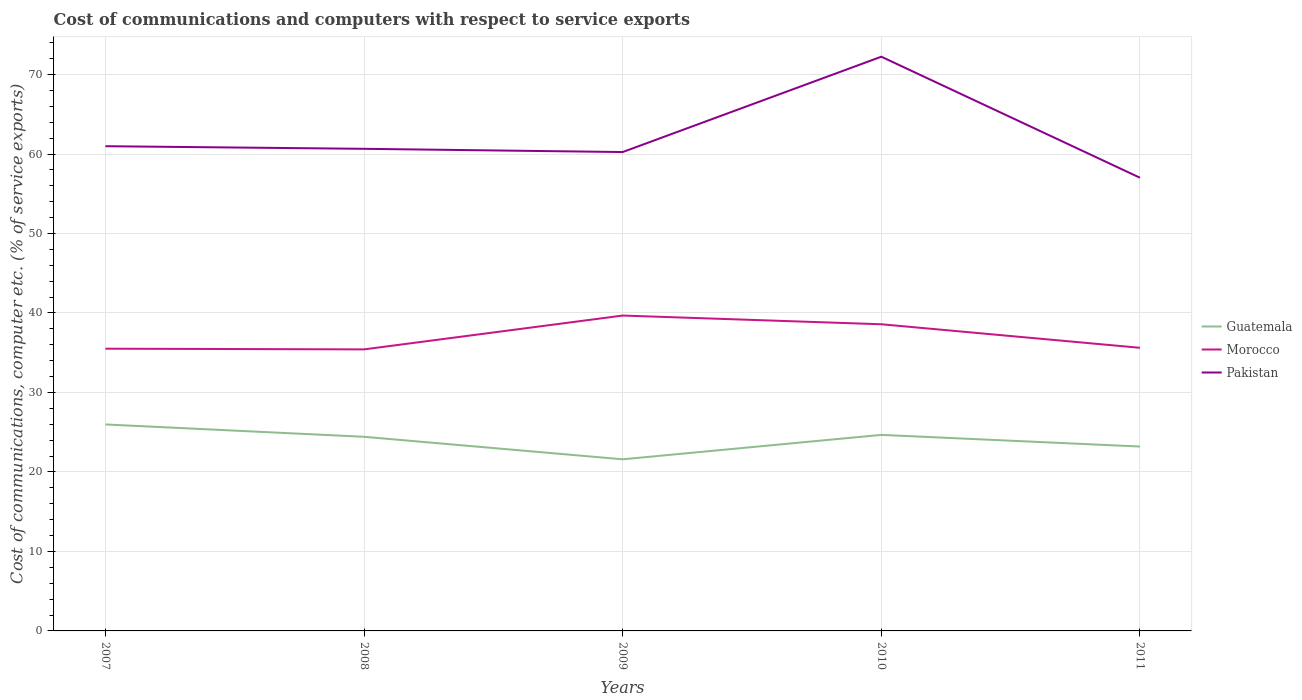Does the line corresponding to Pakistan intersect with the line corresponding to Guatemala?
Ensure brevity in your answer.  No. Is the number of lines equal to the number of legend labels?
Give a very brief answer. Yes. Across all years, what is the maximum cost of communications and computers in Morocco?
Provide a short and direct response. 35.42. What is the total cost of communications and computers in Morocco in the graph?
Ensure brevity in your answer.  -3.16. What is the difference between the highest and the second highest cost of communications and computers in Morocco?
Your answer should be very brief. 4.26. What is the difference between the highest and the lowest cost of communications and computers in Morocco?
Provide a short and direct response. 2. What is the difference between two consecutive major ticks on the Y-axis?
Make the answer very short. 10. Does the graph contain grids?
Your response must be concise. Yes. How many legend labels are there?
Make the answer very short. 3. How are the legend labels stacked?
Your answer should be compact. Vertical. What is the title of the graph?
Keep it short and to the point. Cost of communications and computers with respect to service exports. Does "Georgia" appear as one of the legend labels in the graph?
Offer a very short reply. No. What is the label or title of the X-axis?
Your answer should be very brief. Years. What is the label or title of the Y-axis?
Offer a very short reply. Cost of communications, computer etc. (% of service exports). What is the Cost of communications, computer etc. (% of service exports) of Guatemala in 2007?
Provide a short and direct response. 25.98. What is the Cost of communications, computer etc. (% of service exports) of Morocco in 2007?
Offer a very short reply. 35.51. What is the Cost of communications, computer etc. (% of service exports) in Pakistan in 2007?
Provide a succinct answer. 60.98. What is the Cost of communications, computer etc. (% of service exports) in Guatemala in 2008?
Offer a very short reply. 24.42. What is the Cost of communications, computer etc. (% of service exports) of Morocco in 2008?
Offer a very short reply. 35.42. What is the Cost of communications, computer etc. (% of service exports) of Pakistan in 2008?
Ensure brevity in your answer.  60.65. What is the Cost of communications, computer etc. (% of service exports) in Guatemala in 2009?
Ensure brevity in your answer.  21.59. What is the Cost of communications, computer etc. (% of service exports) in Morocco in 2009?
Make the answer very short. 39.68. What is the Cost of communications, computer etc. (% of service exports) of Pakistan in 2009?
Provide a short and direct response. 60.25. What is the Cost of communications, computer etc. (% of service exports) of Guatemala in 2010?
Keep it short and to the point. 24.66. What is the Cost of communications, computer etc. (% of service exports) of Morocco in 2010?
Offer a very short reply. 38.58. What is the Cost of communications, computer etc. (% of service exports) of Pakistan in 2010?
Give a very brief answer. 72.24. What is the Cost of communications, computer etc. (% of service exports) in Guatemala in 2011?
Provide a short and direct response. 23.2. What is the Cost of communications, computer etc. (% of service exports) of Morocco in 2011?
Offer a very short reply. 35.62. What is the Cost of communications, computer etc. (% of service exports) in Pakistan in 2011?
Your answer should be compact. 57.02. Across all years, what is the maximum Cost of communications, computer etc. (% of service exports) in Guatemala?
Your answer should be very brief. 25.98. Across all years, what is the maximum Cost of communications, computer etc. (% of service exports) in Morocco?
Keep it short and to the point. 39.68. Across all years, what is the maximum Cost of communications, computer etc. (% of service exports) of Pakistan?
Provide a succinct answer. 72.24. Across all years, what is the minimum Cost of communications, computer etc. (% of service exports) in Guatemala?
Offer a terse response. 21.59. Across all years, what is the minimum Cost of communications, computer etc. (% of service exports) of Morocco?
Your answer should be compact. 35.42. Across all years, what is the minimum Cost of communications, computer etc. (% of service exports) of Pakistan?
Provide a succinct answer. 57.02. What is the total Cost of communications, computer etc. (% of service exports) in Guatemala in the graph?
Ensure brevity in your answer.  119.85. What is the total Cost of communications, computer etc. (% of service exports) in Morocco in the graph?
Your answer should be very brief. 184.81. What is the total Cost of communications, computer etc. (% of service exports) in Pakistan in the graph?
Make the answer very short. 311.15. What is the difference between the Cost of communications, computer etc. (% of service exports) of Guatemala in 2007 and that in 2008?
Ensure brevity in your answer.  1.55. What is the difference between the Cost of communications, computer etc. (% of service exports) in Morocco in 2007 and that in 2008?
Make the answer very short. 0.09. What is the difference between the Cost of communications, computer etc. (% of service exports) in Pakistan in 2007 and that in 2008?
Your response must be concise. 0.33. What is the difference between the Cost of communications, computer etc. (% of service exports) of Guatemala in 2007 and that in 2009?
Make the answer very short. 4.38. What is the difference between the Cost of communications, computer etc. (% of service exports) in Morocco in 2007 and that in 2009?
Make the answer very short. -4.17. What is the difference between the Cost of communications, computer etc. (% of service exports) of Pakistan in 2007 and that in 2009?
Offer a terse response. 0.74. What is the difference between the Cost of communications, computer etc. (% of service exports) in Guatemala in 2007 and that in 2010?
Keep it short and to the point. 1.31. What is the difference between the Cost of communications, computer etc. (% of service exports) of Morocco in 2007 and that in 2010?
Your response must be concise. -3.07. What is the difference between the Cost of communications, computer etc. (% of service exports) of Pakistan in 2007 and that in 2010?
Offer a terse response. -11.26. What is the difference between the Cost of communications, computer etc. (% of service exports) of Guatemala in 2007 and that in 2011?
Ensure brevity in your answer.  2.78. What is the difference between the Cost of communications, computer etc. (% of service exports) of Morocco in 2007 and that in 2011?
Ensure brevity in your answer.  -0.11. What is the difference between the Cost of communications, computer etc. (% of service exports) in Pakistan in 2007 and that in 2011?
Provide a short and direct response. 3.96. What is the difference between the Cost of communications, computer etc. (% of service exports) in Guatemala in 2008 and that in 2009?
Your response must be concise. 2.83. What is the difference between the Cost of communications, computer etc. (% of service exports) in Morocco in 2008 and that in 2009?
Your answer should be very brief. -4.26. What is the difference between the Cost of communications, computer etc. (% of service exports) in Pakistan in 2008 and that in 2009?
Offer a very short reply. 0.41. What is the difference between the Cost of communications, computer etc. (% of service exports) in Guatemala in 2008 and that in 2010?
Offer a very short reply. -0.24. What is the difference between the Cost of communications, computer etc. (% of service exports) of Morocco in 2008 and that in 2010?
Ensure brevity in your answer.  -3.16. What is the difference between the Cost of communications, computer etc. (% of service exports) of Pakistan in 2008 and that in 2010?
Ensure brevity in your answer.  -11.59. What is the difference between the Cost of communications, computer etc. (% of service exports) of Guatemala in 2008 and that in 2011?
Your answer should be compact. 1.22. What is the difference between the Cost of communications, computer etc. (% of service exports) in Morocco in 2008 and that in 2011?
Your answer should be very brief. -0.2. What is the difference between the Cost of communications, computer etc. (% of service exports) of Pakistan in 2008 and that in 2011?
Make the answer very short. 3.64. What is the difference between the Cost of communications, computer etc. (% of service exports) in Guatemala in 2009 and that in 2010?
Keep it short and to the point. -3.07. What is the difference between the Cost of communications, computer etc. (% of service exports) in Morocco in 2009 and that in 2010?
Provide a succinct answer. 1.1. What is the difference between the Cost of communications, computer etc. (% of service exports) of Pakistan in 2009 and that in 2010?
Provide a succinct answer. -12. What is the difference between the Cost of communications, computer etc. (% of service exports) in Guatemala in 2009 and that in 2011?
Your response must be concise. -1.61. What is the difference between the Cost of communications, computer etc. (% of service exports) in Morocco in 2009 and that in 2011?
Make the answer very short. 4.06. What is the difference between the Cost of communications, computer etc. (% of service exports) of Pakistan in 2009 and that in 2011?
Your answer should be very brief. 3.23. What is the difference between the Cost of communications, computer etc. (% of service exports) of Guatemala in 2010 and that in 2011?
Your answer should be very brief. 1.47. What is the difference between the Cost of communications, computer etc. (% of service exports) in Morocco in 2010 and that in 2011?
Ensure brevity in your answer.  2.96. What is the difference between the Cost of communications, computer etc. (% of service exports) of Pakistan in 2010 and that in 2011?
Provide a succinct answer. 15.22. What is the difference between the Cost of communications, computer etc. (% of service exports) in Guatemala in 2007 and the Cost of communications, computer etc. (% of service exports) in Morocco in 2008?
Provide a succinct answer. -9.44. What is the difference between the Cost of communications, computer etc. (% of service exports) of Guatemala in 2007 and the Cost of communications, computer etc. (% of service exports) of Pakistan in 2008?
Offer a very short reply. -34.68. What is the difference between the Cost of communications, computer etc. (% of service exports) of Morocco in 2007 and the Cost of communications, computer etc. (% of service exports) of Pakistan in 2008?
Offer a terse response. -25.15. What is the difference between the Cost of communications, computer etc. (% of service exports) in Guatemala in 2007 and the Cost of communications, computer etc. (% of service exports) in Morocco in 2009?
Provide a succinct answer. -13.7. What is the difference between the Cost of communications, computer etc. (% of service exports) in Guatemala in 2007 and the Cost of communications, computer etc. (% of service exports) in Pakistan in 2009?
Provide a succinct answer. -34.27. What is the difference between the Cost of communications, computer etc. (% of service exports) of Morocco in 2007 and the Cost of communications, computer etc. (% of service exports) of Pakistan in 2009?
Your answer should be compact. -24.74. What is the difference between the Cost of communications, computer etc. (% of service exports) in Guatemala in 2007 and the Cost of communications, computer etc. (% of service exports) in Morocco in 2010?
Offer a very short reply. -12.61. What is the difference between the Cost of communications, computer etc. (% of service exports) of Guatemala in 2007 and the Cost of communications, computer etc. (% of service exports) of Pakistan in 2010?
Your response must be concise. -46.27. What is the difference between the Cost of communications, computer etc. (% of service exports) in Morocco in 2007 and the Cost of communications, computer etc. (% of service exports) in Pakistan in 2010?
Your answer should be very brief. -36.74. What is the difference between the Cost of communications, computer etc. (% of service exports) in Guatemala in 2007 and the Cost of communications, computer etc. (% of service exports) in Morocco in 2011?
Keep it short and to the point. -9.64. What is the difference between the Cost of communications, computer etc. (% of service exports) in Guatemala in 2007 and the Cost of communications, computer etc. (% of service exports) in Pakistan in 2011?
Provide a short and direct response. -31.04. What is the difference between the Cost of communications, computer etc. (% of service exports) in Morocco in 2007 and the Cost of communications, computer etc. (% of service exports) in Pakistan in 2011?
Provide a succinct answer. -21.51. What is the difference between the Cost of communications, computer etc. (% of service exports) of Guatemala in 2008 and the Cost of communications, computer etc. (% of service exports) of Morocco in 2009?
Offer a terse response. -15.25. What is the difference between the Cost of communications, computer etc. (% of service exports) in Guatemala in 2008 and the Cost of communications, computer etc. (% of service exports) in Pakistan in 2009?
Offer a very short reply. -35.82. What is the difference between the Cost of communications, computer etc. (% of service exports) in Morocco in 2008 and the Cost of communications, computer etc. (% of service exports) in Pakistan in 2009?
Provide a short and direct response. -24.83. What is the difference between the Cost of communications, computer etc. (% of service exports) of Guatemala in 2008 and the Cost of communications, computer etc. (% of service exports) of Morocco in 2010?
Offer a terse response. -14.16. What is the difference between the Cost of communications, computer etc. (% of service exports) of Guatemala in 2008 and the Cost of communications, computer etc. (% of service exports) of Pakistan in 2010?
Give a very brief answer. -47.82. What is the difference between the Cost of communications, computer etc. (% of service exports) of Morocco in 2008 and the Cost of communications, computer etc. (% of service exports) of Pakistan in 2010?
Make the answer very short. -36.82. What is the difference between the Cost of communications, computer etc. (% of service exports) of Guatemala in 2008 and the Cost of communications, computer etc. (% of service exports) of Morocco in 2011?
Offer a very short reply. -11.2. What is the difference between the Cost of communications, computer etc. (% of service exports) of Guatemala in 2008 and the Cost of communications, computer etc. (% of service exports) of Pakistan in 2011?
Ensure brevity in your answer.  -32.6. What is the difference between the Cost of communications, computer etc. (% of service exports) of Morocco in 2008 and the Cost of communications, computer etc. (% of service exports) of Pakistan in 2011?
Provide a short and direct response. -21.6. What is the difference between the Cost of communications, computer etc. (% of service exports) of Guatemala in 2009 and the Cost of communications, computer etc. (% of service exports) of Morocco in 2010?
Offer a very short reply. -16.99. What is the difference between the Cost of communications, computer etc. (% of service exports) of Guatemala in 2009 and the Cost of communications, computer etc. (% of service exports) of Pakistan in 2010?
Offer a terse response. -50.65. What is the difference between the Cost of communications, computer etc. (% of service exports) of Morocco in 2009 and the Cost of communications, computer etc. (% of service exports) of Pakistan in 2010?
Keep it short and to the point. -32.57. What is the difference between the Cost of communications, computer etc. (% of service exports) in Guatemala in 2009 and the Cost of communications, computer etc. (% of service exports) in Morocco in 2011?
Provide a short and direct response. -14.03. What is the difference between the Cost of communications, computer etc. (% of service exports) of Guatemala in 2009 and the Cost of communications, computer etc. (% of service exports) of Pakistan in 2011?
Keep it short and to the point. -35.43. What is the difference between the Cost of communications, computer etc. (% of service exports) of Morocco in 2009 and the Cost of communications, computer etc. (% of service exports) of Pakistan in 2011?
Make the answer very short. -17.34. What is the difference between the Cost of communications, computer etc. (% of service exports) in Guatemala in 2010 and the Cost of communications, computer etc. (% of service exports) in Morocco in 2011?
Give a very brief answer. -10.96. What is the difference between the Cost of communications, computer etc. (% of service exports) of Guatemala in 2010 and the Cost of communications, computer etc. (% of service exports) of Pakistan in 2011?
Your answer should be compact. -32.36. What is the difference between the Cost of communications, computer etc. (% of service exports) in Morocco in 2010 and the Cost of communications, computer etc. (% of service exports) in Pakistan in 2011?
Give a very brief answer. -18.44. What is the average Cost of communications, computer etc. (% of service exports) in Guatemala per year?
Keep it short and to the point. 23.97. What is the average Cost of communications, computer etc. (% of service exports) in Morocco per year?
Keep it short and to the point. 36.96. What is the average Cost of communications, computer etc. (% of service exports) of Pakistan per year?
Your answer should be very brief. 62.23. In the year 2007, what is the difference between the Cost of communications, computer etc. (% of service exports) in Guatemala and Cost of communications, computer etc. (% of service exports) in Morocco?
Your answer should be very brief. -9.53. In the year 2007, what is the difference between the Cost of communications, computer etc. (% of service exports) of Guatemala and Cost of communications, computer etc. (% of service exports) of Pakistan?
Provide a short and direct response. -35.01. In the year 2007, what is the difference between the Cost of communications, computer etc. (% of service exports) of Morocco and Cost of communications, computer etc. (% of service exports) of Pakistan?
Make the answer very short. -25.48. In the year 2008, what is the difference between the Cost of communications, computer etc. (% of service exports) in Guatemala and Cost of communications, computer etc. (% of service exports) in Morocco?
Offer a terse response. -11. In the year 2008, what is the difference between the Cost of communications, computer etc. (% of service exports) of Guatemala and Cost of communications, computer etc. (% of service exports) of Pakistan?
Make the answer very short. -36.23. In the year 2008, what is the difference between the Cost of communications, computer etc. (% of service exports) in Morocco and Cost of communications, computer etc. (% of service exports) in Pakistan?
Your answer should be very brief. -25.23. In the year 2009, what is the difference between the Cost of communications, computer etc. (% of service exports) in Guatemala and Cost of communications, computer etc. (% of service exports) in Morocco?
Give a very brief answer. -18.09. In the year 2009, what is the difference between the Cost of communications, computer etc. (% of service exports) in Guatemala and Cost of communications, computer etc. (% of service exports) in Pakistan?
Ensure brevity in your answer.  -38.66. In the year 2009, what is the difference between the Cost of communications, computer etc. (% of service exports) in Morocco and Cost of communications, computer etc. (% of service exports) in Pakistan?
Give a very brief answer. -20.57. In the year 2010, what is the difference between the Cost of communications, computer etc. (% of service exports) of Guatemala and Cost of communications, computer etc. (% of service exports) of Morocco?
Ensure brevity in your answer.  -13.92. In the year 2010, what is the difference between the Cost of communications, computer etc. (% of service exports) of Guatemala and Cost of communications, computer etc. (% of service exports) of Pakistan?
Offer a very short reply. -47.58. In the year 2010, what is the difference between the Cost of communications, computer etc. (% of service exports) of Morocco and Cost of communications, computer etc. (% of service exports) of Pakistan?
Make the answer very short. -33.66. In the year 2011, what is the difference between the Cost of communications, computer etc. (% of service exports) of Guatemala and Cost of communications, computer etc. (% of service exports) of Morocco?
Ensure brevity in your answer.  -12.42. In the year 2011, what is the difference between the Cost of communications, computer etc. (% of service exports) in Guatemala and Cost of communications, computer etc. (% of service exports) in Pakistan?
Offer a terse response. -33.82. In the year 2011, what is the difference between the Cost of communications, computer etc. (% of service exports) of Morocco and Cost of communications, computer etc. (% of service exports) of Pakistan?
Give a very brief answer. -21.4. What is the ratio of the Cost of communications, computer etc. (% of service exports) of Guatemala in 2007 to that in 2008?
Offer a terse response. 1.06. What is the ratio of the Cost of communications, computer etc. (% of service exports) of Morocco in 2007 to that in 2008?
Give a very brief answer. 1. What is the ratio of the Cost of communications, computer etc. (% of service exports) in Pakistan in 2007 to that in 2008?
Give a very brief answer. 1.01. What is the ratio of the Cost of communications, computer etc. (% of service exports) in Guatemala in 2007 to that in 2009?
Keep it short and to the point. 1.2. What is the ratio of the Cost of communications, computer etc. (% of service exports) of Morocco in 2007 to that in 2009?
Make the answer very short. 0.89. What is the ratio of the Cost of communications, computer etc. (% of service exports) in Pakistan in 2007 to that in 2009?
Make the answer very short. 1.01. What is the ratio of the Cost of communications, computer etc. (% of service exports) in Guatemala in 2007 to that in 2010?
Give a very brief answer. 1.05. What is the ratio of the Cost of communications, computer etc. (% of service exports) in Morocco in 2007 to that in 2010?
Your answer should be compact. 0.92. What is the ratio of the Cost of communications, computer etc. (% of service exports) in Pakistan in 2007 to that in 2010?
Provide a succinct answer. 0.84. What is the ratio of the Cost of communications, computer etc. (% of service exports) of Guatemala in 2007 to that in 2011?
Give a very brief answer. 1.12. What is the ratio of the Cost of communications, computer etc. (% of service exports) of Pakistan in 2007 to that in 2011?
Your answer should be very brief. 1.07. What is the ratio of the Cost of communications, computer etc. (% of service exports) of Guatemala in 2008 to that in 2009?
Your response must be concise. 1.13. What is the ratio of the Cost of communications, computer etc. (% of service exports) of Morocco in 2008 to that in 2009?
Give a very brief answer. 0.89. What is the ratio of the Cost of communications, computer etc. (% of service exports) in Pakistan in 2008 to that in 2009?
Offer a very short reply. 1.01. What is the ratio of the Cost of communications, computer etc. (% of service exports) in Guatemala in 2008 to that in 2010?
Offer a very short reply. 0.99. What is the ratio of the Cost of communications, computer etc. (% of service exports) in Morocco in 2008 to that in 2010?
Offer a terse response. 0.92. What is the ratio of the Cost of communications, computer etc. (% of service exports) of Pakistan in 2008 to that in 2010?
Give a very brief answer. 0.84. What is the ratio of the Cost of communications, computer etc. (% of service exports) of Guatemala in 2008 to that in 2011?
Ensure brevity in your answer.  1.05. What is the ratio of the Cost of communications, computer etc. (% of service exports) in Pakistan in 2008 to that in 2011?
Give a very brief answer. 1.06. What is the ratio of the Cost of communications, computer etc. (% of service exports) of Guatemala in 2009 to that in 2010?
Give a very brief answer. 0.88. What is the ratio of the Cost of communications, computer etc. (% of service exports) in Morocco in 2009 to that in 2010?
Provide a short and direct response. 1.03. What is the ratio of the Cost of communications, computer etc. (% of service exports) of Pakistan in 2009 to that in 2010?
Your answer should be compact. 0.83. What is the ratio of the Cost of communications, computer etc. (% of service exports) in Guatemala in 2009 to that in 2011?
Ensure brevity in your answer.  0.93. What is the ratio of the Cost of communications, computer etc. (% of service exports) in Morocco in 2009 to that in 2011?
Ensure brevity in your answer.  1.11. What is the ratio of the Cost of communications, computer etc. (% of service exports) in Pakistan in 2009 to that in 2011?
Your answer should be compact. 1.06. What is the ratio of the Cost of communications, computer etc. (% of service exports) in Guatemala in 2010 to that in 2011?
Offer a very short reply. 1.06. What is the ratio of the Cost of communications, computer etc. (% of service exports) of Morocco in 2010 to that in 2011?
Ensure brevity in your answer.  1.08. What is the ratio of the Cost of communications, computer etc. (% of service exports) of Pakistan in 2010 to that in 2011?
Provide a short and direct response. 1.27. What is the difference between the highest and the second highest Cost of communications, computer etc. (% of service exports) of Guatemala?
Offer a very short reply. 1.31. What is the difference between the highest and the second highest Cost of communications, computer etc. (% of service exports) of Morocco?
Ensure brevity in your answer.  1.1. What is the difference between the highest and the second highest Cost of communications, computer etc. (% of service exports) of Pakistan?
Your answer should be compact. 11.26. What is the difference between the highest and the lowest Cost of communications, computer etc. (% of service exports) in Guatemala?
Your response must be concise. 4.38. What is the difference between the highest and the lowest Cost of communications, computer etc. (% of service exports) in Morocco?
Offer a terse response. 4.26. What is the difference between the highest and the lowest Cost of communications, computer etc. (% of service exports) of Pakistan?
Make the answer very short. 15.22. 